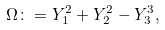<formula> <loc_0><loc_0><loc_500><loc_500>\Omega \colon = Y _ { 1 } ^ { 2 } + Y _ { 2 } ^ { 2 } - Y _ { 3 } ^ { 3 } ,</formula> 